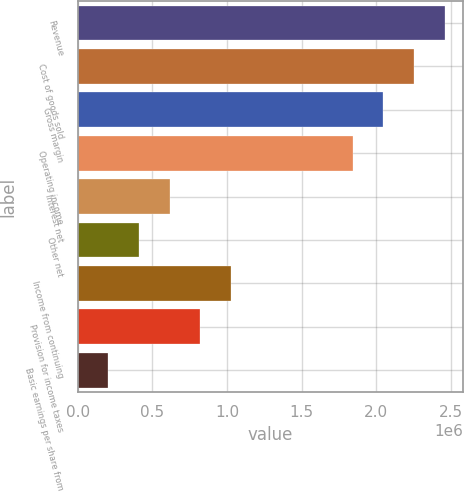<chart> <loc_0><loc_0><loc_500><loc_500><bar_chart><fcel>Revenue<fcel>Cost of goods sold<fcel>Gross margin<fcel>Operating income<fcel>Interest net<fcel>Other net<fcel>Income from continuing<fcel>Provision for income taxes<fcel>Basic earnings per share from<nl><fcel>2.45753e+06<fcel>2.25274e+06<fcel>2.04794e+06<fcel>1.84315e+06<fcel>614383<fcel>409589<fcel>1.02397e+06<fcel>819177<fcel>204795<nl></chart> 